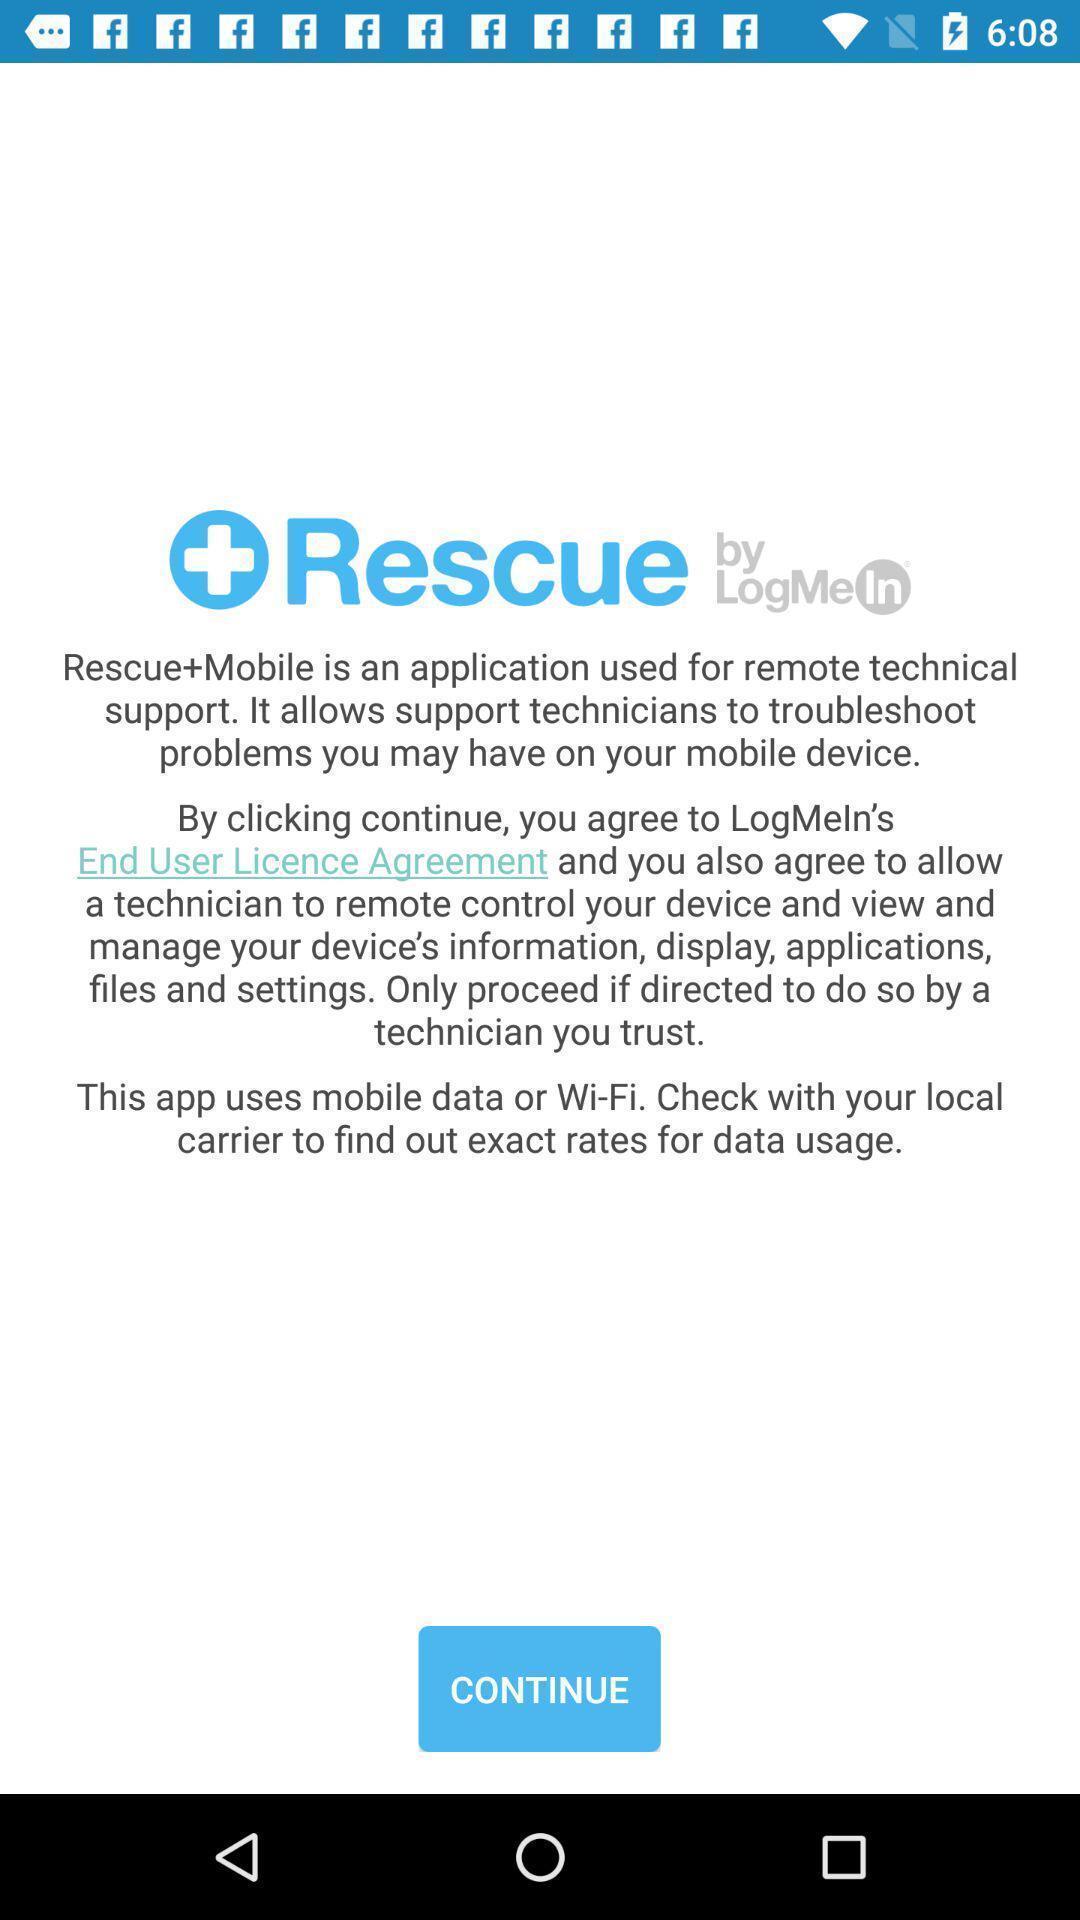Provide a detailed account of this screenshot. Screen showing info about the app. 